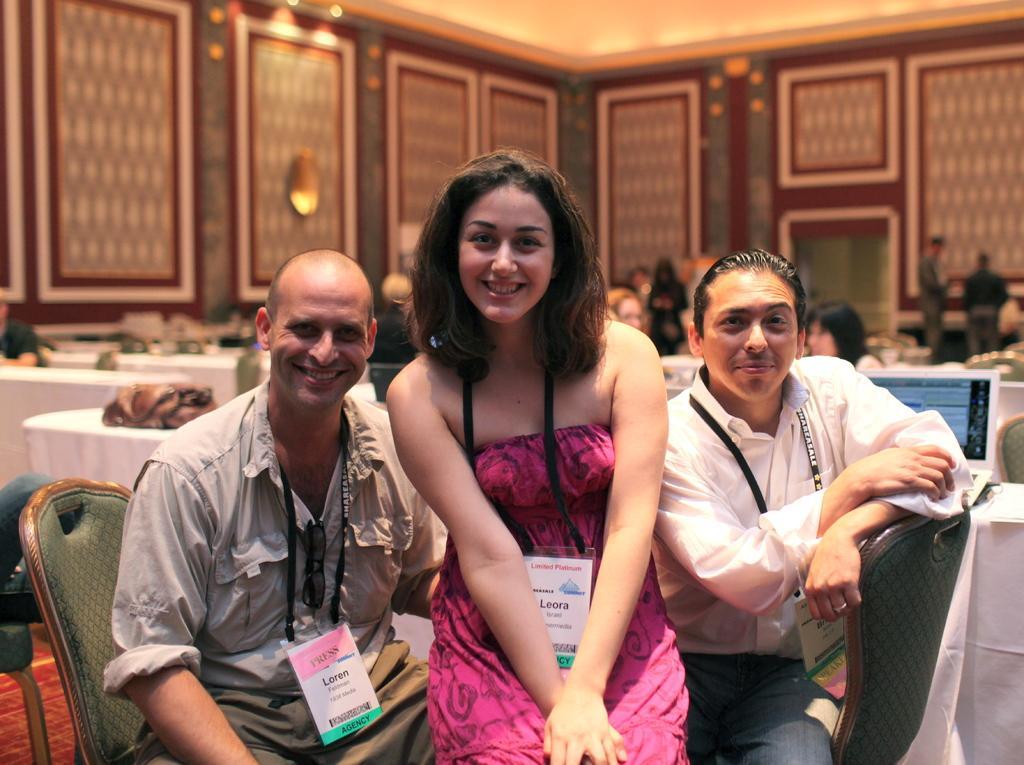Could you give a brief overview of what you see in this image? There are two men and two women sitting and smiling. They wore badges. These are the tables covered with white cloth. I can see few objects placed on it. In the background, there are few people standing and few people sitting. These are the lamps attached to the wall. 